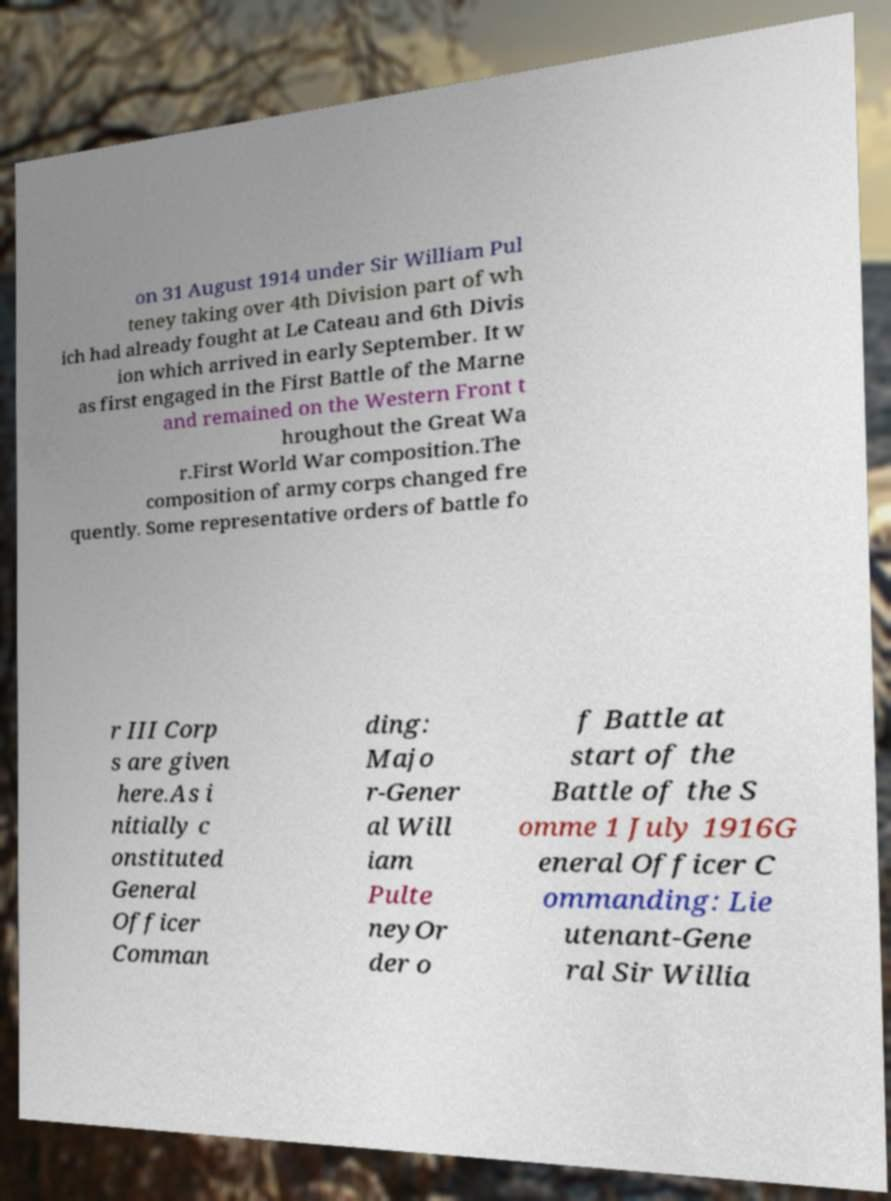Can you read and provide the text displayed in the image?This photo seems to have some interesting text. Can you extract and type it out for me? on 31 August 1914 under Sir William Pul teney taking over 4th Division part of wh ich had already fought at Le Cateau and 6th Divis ion which arrived in early September. It w as first engaged in the First Battle of the Marne and remained on the Western Front t hroughout the Great Wa r.First World War composition.The composition of army corps changed fre quently. Some representative orders of battle fo r III Corp s are given here.As i nitially c onstituted General Officer Comman ding: Majo r-Gener al Will iam Pulte neyOr der o f Battle at start of the Battle of the S omme 1 July 1916G eneral Officer C ommanding: Lie utenant-Gene ral Sir Willia 